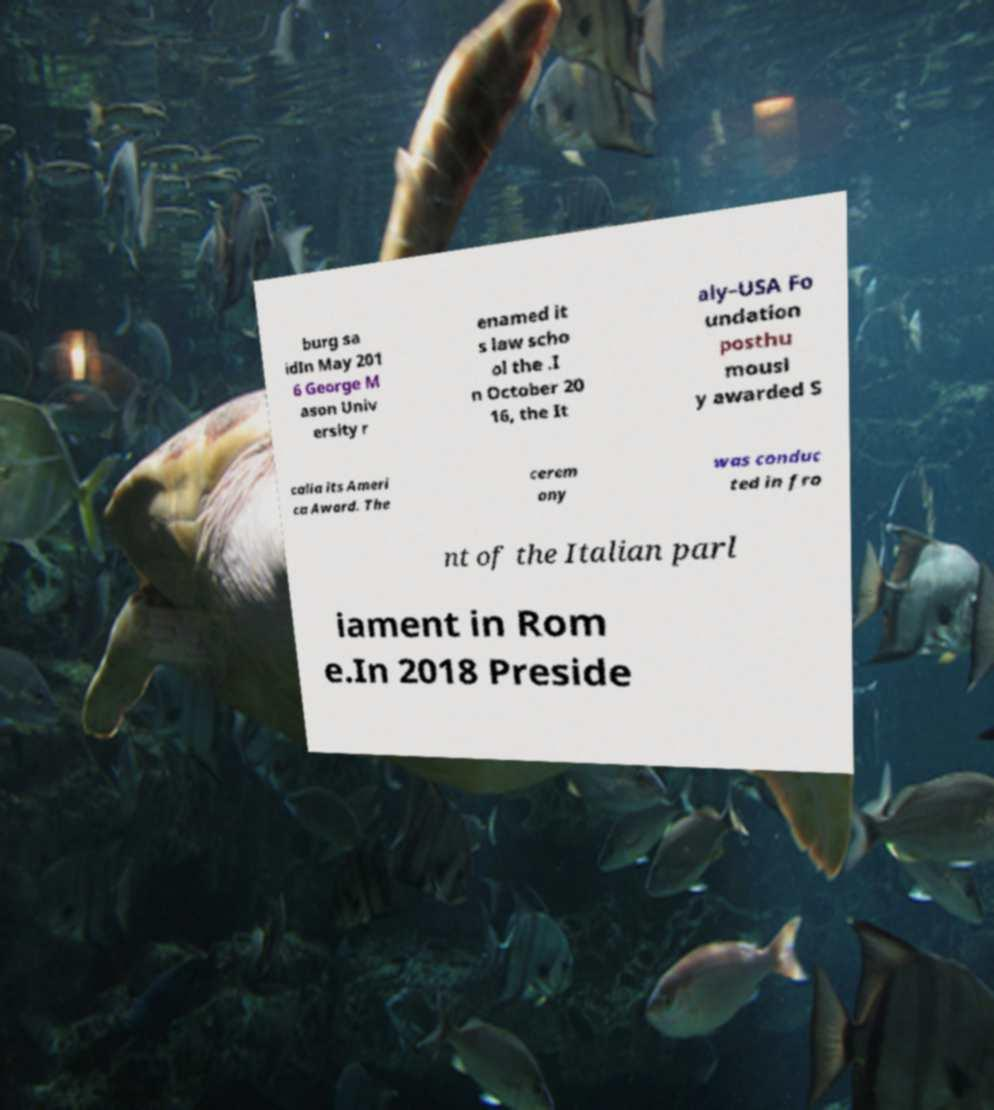What messages or text are displayed in this image? I need them in a readable, typed format. burg sa idIn May 201 6 George M ason Univ ersity r enamed it s law scho ol the .I n October 20 16, the It aly–USA Fo undation posthu mousl y awarded S calia its Ameri ca Award. The cerem ony was conduc ted in fro nt of the Italian parl iament in Rom e.In 2018 Preside 